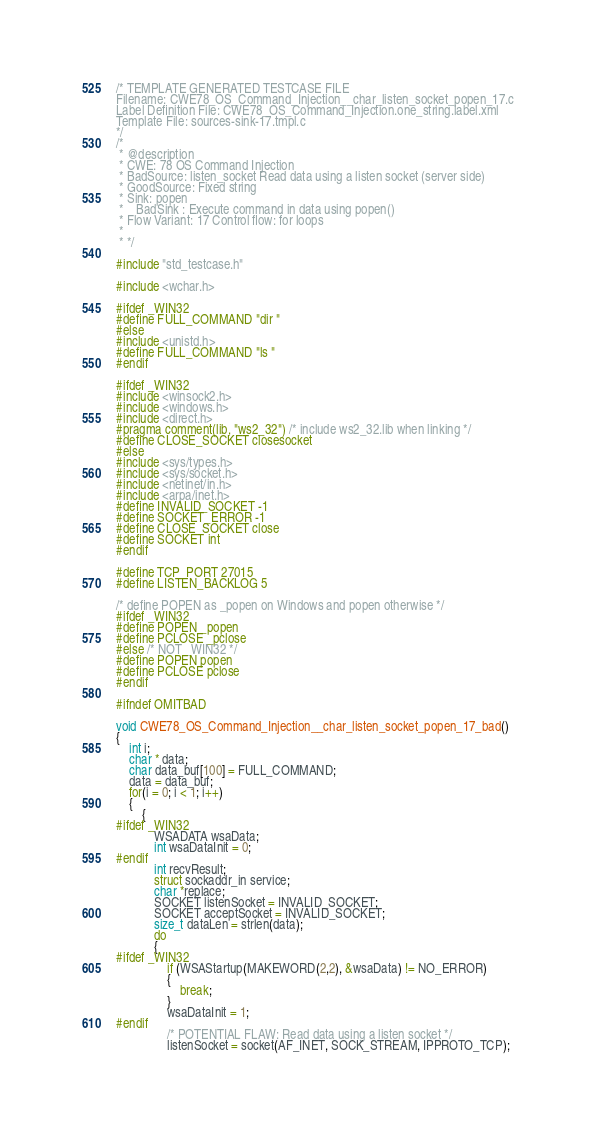Convert code to text. <code><loc_0><loc_0><loc_500><loc_500><_C_>/* TEMPLATE GENERATED TESTCASE FILE
Filename: CWE78_OS_Command_Injection__char_listen_socket_popen_17.c
Label Definition File: CWE78_OS_Command_Injection.one_string.label.xml
Template File: sources-sink-17.tmpl.c
*/
/*
 * @description
 * CWE: 78 OS Command Injection
 * BadSource: listen_socket Read data using a listen socket (server side)
 * GoodSource: Fixed string
 * Sink: popen
 *    BadSink : Execute command in data using popen()
 * Flow Variant: 17 Control flow: for loops
 *
 * */

#include "std_testcase.h"

#include <wchar.h>

#ifdef _WIN32
#define FULL_COMMAND "dir "
#else
#include <unistd.h>
#define FULL_COMMAND "ls "
#endif

#ifdef _WIN32
#include <winsock2.h>
#include <windows.h>
#include <direct.h>
#pragma comment(lib, "ws2_32") /* include ws2_32.lib when linking */
#define CLOSE_SOCKET closesocket
#else
#include <sys/types.h>
#include <sys/socket.h>
#include <netinet/in.h>
#include <arpa/inet.h>
#define INVALID_SOCKET -1
#define SOCKET_ERROR -1
#define CLOSE_SOCKET close
#define SOCKET int
#endif

#define TCP_PORT 27015
#define LISTEN_BACKLOG 5

/* define POPEN as _popen on Windows and popen otherwise */
#ifdef _WIN32
#define POPEN _popen
#define PCLOSE _pclose
#else /* NOT _WIN32 */
#define POPEN popen
#define PCLOSE pclose
#endif

#ifndef OMITBAD

void CWE78_OS_Command_Injection__char_listen_socket_popen_17_bad()
{
    int i;
    char * data;
    char data_buf[100] = FULL_COMMAND;
    data = data_buf;
    for(i = 0; i < 1; i++)
    {
        {
#ifdef _WIN32
            WSADATA wsaData;
            int wsaDataInit = 0;
#endif
            int recvResult;
            struct sockaddr_in service;
            char *replace;
            SOCKET listenSocket = INVALID_SOCKET;
            SOCKET acceptSocket = INVALID_SOCKET;
            size_t dataLen = strlen(data);
            do
            {
#ifdef _WIN32
                if (WSAStartup(MAKEWORD(2,2), &wsaData) != NO_ERROR)
                {
                    break;
                }
                wsaDataInit = 1;
#endif
                /* POTENTIAL FLAW: Read data using a listen socket */
                listenSocket = socket(AF_INET, SOCK_STREAM, IPPROTO_TCP);</code> 